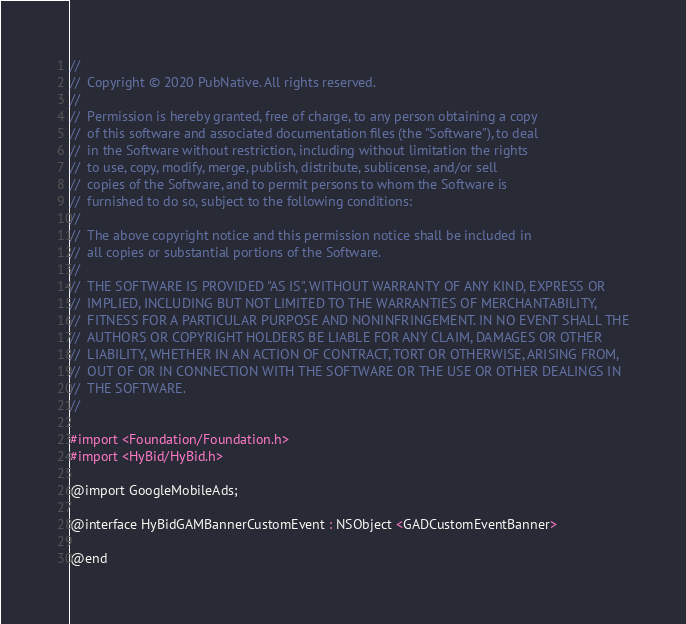Convert code to text. <code><loc_0><loc_0><loc_500><loc_500><_C_>//
//  Copyright © 2020 PubNative. All rights reserved.
//
//  Permission is hereby granted, free of charge, to any person obtaining a copy
//  of this software and associated documentation files (the "Software"), to deal
//  in the Software without restriction, including without limitation the rights
//  to use, copy, modify, merge, publish, distribute, sublicense, and/or sell
//  copies of the Software, and to permit persons to whom the Software is
//  furnished to do so, subject to the following conditions:
//
//  The above copyright notice and this permission notice shall be included in
//  all copies or substantial portions of the Software.
//
//  THE SOFTWARE IS PROVIDED "AS IS", WITHOUT WARRANTY OF ANY KIND, EXPRESS OR
//  IMPLIED, INCLUDING BUT NOT LIMITED TO THE WARRANTIES OF MERCHANTABILITY,
//  FITNESS FOR A PARTICULAR PURPOSE AND NONINFRINGEMENT. IN NO EVENT SHALL THE
//  AUTHORS OR COPYRIGHT HOLDERS BE LIABLE FOR ANY CLAIM, DAMAGES OR OTHER
//  LIABILITY, WHETHER IN AN ACTION OF CONTRACT, TORT OR OTHERWISE, ARISING FROM,
//  OUT OF OR IN CONNECTION WITH THE SOFTWARE OR THE USE OR OTHER DEALINGS IN
//  THE SOFTWARE.
//

#import <Foundation/Foundation.h>
#import <HyBid/HyBid.h>

@import GoogleMobileAds;

@interface HyBidGAMBannerCustomEvent : NSObject <GADCustomEventBanner>

@end
</code> 